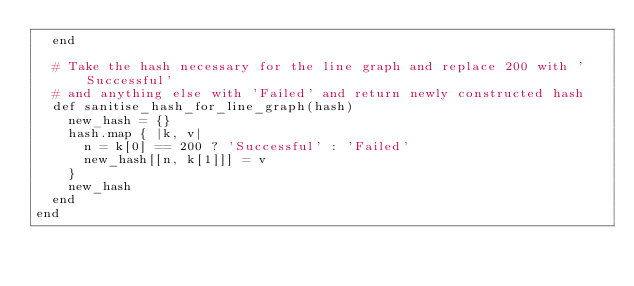Convert code to text. <code><loc_0><loc_0><loc_500><loc_500><_Ruby_>  end

  # Take the hash necessary for the line graph and replace 200 with 'Successful'
  # and anything else with 'Failed' and return newly constructed hash
  def sanitise_hash_for_line_graph(hash)
    new_hash = {}
    hash.map { |k, v|
      n = k[0] == 200 ? 'Successful' : 'Failed'
      new_hash[[n, k[1]]] = v
    }
    new_hash
  end
end
</code> 